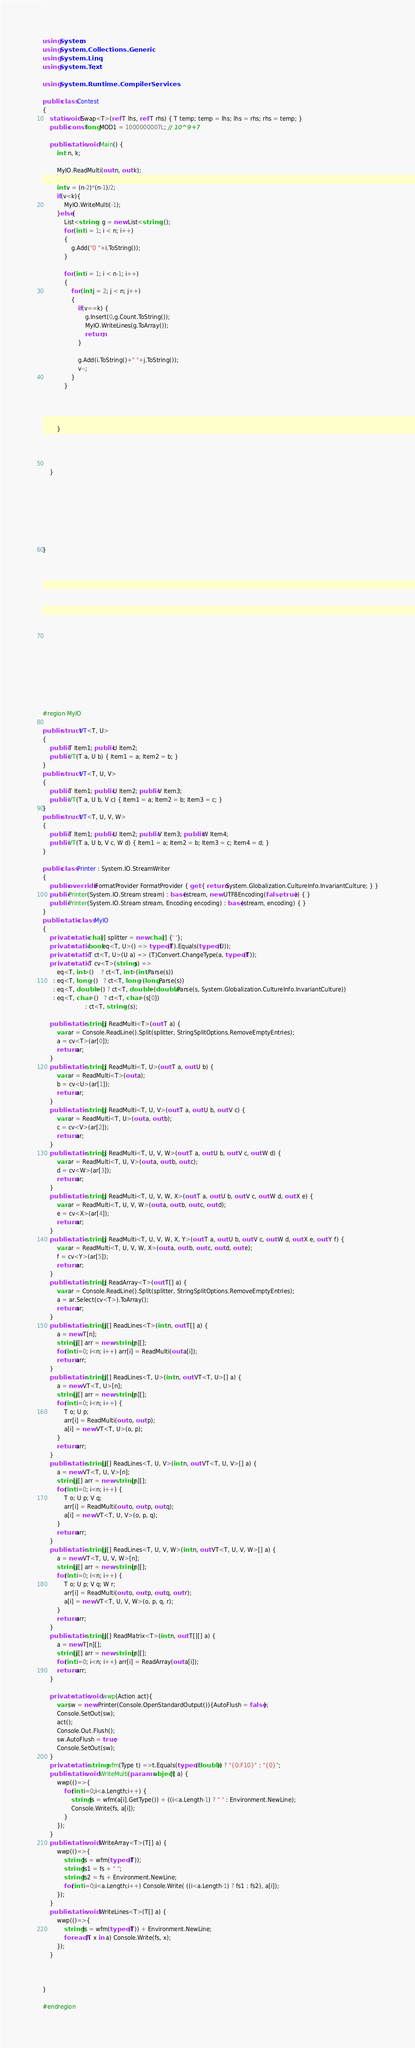Convert code to text. <code><loc_0><loc_0><loc_500><loc_500><_C#_>using System;
using System.Collections.Generic;
using System.Linq;
using System.Text;

using System.Runtime.CompilerServices;

public class Contest
{
	static void Swap<T>(ref T lhs, ref T rhs) { T temp; temp = lhs; lhs = rhs; rhs = temp; }
	public const long MOD1 = 1000000007L; // 10^9+7

	public static void Main() {
		int  n, k;

		MyIO.ReadMulti(out n, out k);
 
		int v = (n-2)*(n-1)/2;
		if(v<k){
			MyIO.WriteMulti(-1);
		}else{
			List<string> g = new List<string>();
			for (int i = 1; i < n; i++)
			{
				g.Add("0 "+i.ToString());
			}

			for (int i = 1; i < n-1; i++)
			{
				for (int j = 2; j < n; j++)
				{
					if(v==k) {
						g.Insert(0,g.Count.ToString());
						MyIO.WriteLines(g.ToArray());
						return;
					}				

					g.Add(i.ToString()+" "+j.ToString());
					v--;
				}				
			}




		}



 
	}








}


















#region MyIO

public struct VT<T, U>
{
	public T Item1; public U Item2;
    public VT(T a, U b) { Item1 = a; Item2 = b; }
}
public struct VT<T, U, V>
{
	public T Item1; public U Item2; public V Item3;
    public VT(T a, U b, V c) { Item1 = a; Item2 = b; Item3 = c; }
}
public struct VT<T, U, V, W>
{
	public T Item1; public U Item2; public V Item3; public W Item4;
    public VT(T a, U b, V c, W d) { Item1 = a; Item2 = b; Item3 = c; Item4 = d; }
}

public class Printer : System.IO.StreamWriter
{
	public override IFormatProvider FormatProvider { get { return System.Globalization.CultureInfo.InvariantCulture; } }
	public Printer(System.IO.Stream stream) : base(stream, new UTF8Encoding(false, true)) { }
	public Printer(System.IO.Stream stream, Encoding encoding) : base(stream, encoding) { }
}
public static class MyIO
{
	private static char[] splitter = new char[] {' '};
	private static bool eq<T, U>() => typeof(T).Equals(typeof(U));
	private static T ct<T, U>(U a) => (T)Convert.ChangeType(a, typeof(T));
	private static T cv<T>(string s) =>
		eq<T, int>()    ? ct<T, int>(int.Parse(s))
	  : eq<T, long>()   ? ct<T, long>(long.Parse(s))
	  : eq<T, double>() ? ct<T, double>(double.Parse(s, System.Globalization.CultureInfo.InvariantCulture))
	  : eq<T, char>()   ? ct<T, char>(s[0])
						: ct<T, string>(s);
			
	public static string[] ReadMulti<T>(out T a) {
		var ar = Console.ReadLine().Split(splitter, StringSplitOptions.RemoveEmptyEntries); 
		a = cv<T>(ar[0]);
		return ar;
	}
	public static string[] ReadMulti<T, U>(out T a, out U b) {
		var ar = ReadMulti<T>(out a); 
        b = cv<U>(ar[1]);
		return ar;
	}
	public static string[] ReadMulti<T, U, V>(out T a, out U b, out V c) {
		var ar = ReadMulti<T, U>(out a, out b); 
        c = cv<V>(ar[2]);
		return ar;
	}
	public static string[] ReadMulti<T, U, V, W>(out T a, out U b, out V c, out W d) {
		var ar = ReadMulti<T, U, V>(out a, out b, out c); 
        d = cv<W>(ar[3]);
		return ar;
	}
	public static string[] ReadMulti<T, U, V, W, X>(out T a, out U b, out V c, out W d, out X e) {
		var ar = ReadMulti<T, U, V, W>(out a, out b, out c, out d); 
        e = cv<X>(ar[4]);
		return ar;
	}
	public static string[] ReadMulti<T, U, V, W, X, Y>(out T a, out U b, out V c, out W d, out X e, out Y f) {
		var ar = ReadMulti<T, U, V, W, X>(out a, out b, out c, out d, out e); 
        f = cv<Y>(ar[5]);
		return ar;
	}
	public static string[] ReadArray<T>(out T[] a) {		
		var ar = Console.ReadLine().Split(splitter, StringSplitOptions.RemoveEmptyEntries);
		a = ar.Select(cv<T>).ToArray();
		return ar;
	}		
	public static string[][] ReadLines<T>(int n, out T[] a) {
		a = new T[n];
		string[][] arr = new string[n][];
		for(int i=0; i<n; i++) arr[i] = ReadMulti(out a[i]);
		return arr;
	}
	public static string[][] ReadLines<T, U>(int n, out VT<T, U>[] a) {
		a = new VT<T, U>[n];
		string[][] arr = new string[n][];
		for(int i=0; i<n; i++) {
			T o; U p;
			arr[i] = ReadMulti(out o, out p);
			a[i] = new VT<T, U>(o, p);
		}
		return arr;
	}
	public static string[][] ReadLines<T, U, V>(int n, out VT<T, U, V>[] a) {
		a = new VT<T, U, V>[n];
		string[][] arr = new string[n][];
		for(int i=0; i<n; i++) {
			T o; U p; V q;
			arr[i] = ReadMulti(out o, out p, out q);
			a[i] = new VT<T, U, V>(o, p, q);
		}
		return arr;
	}
	public static string[][] ReadLines<T, U, V, W>(int n, out VT<T, U, V, W>[] a) {
		a = new VT<T, U, V, W>[n];
		string[][] arr = new string[n][];
		for(int i=0; i<n; i++) {
			T o; U p; V q; W r;
			arr[i] = ReadMulti(out o, out p, out q, out r);
			a[i] = new VT<T, U, V, W>(o, p, q, r);
		}
		return arr;
	}
	public static string[][] ReadMatrix<T>(int n, out T[][] a) {
		a = new T[n][];
		string[][] arr = new string[n][];
		for(int i=0; i<n; i++) arr[i] = ReadArray(out a[i]);
		return arr;
	}

	private static void wwp(Action act){
		var sw = new Printer(Console.OpenStandardOutput()){AutoFlush = false};
		Console.SetOut(sw);
		act();
		Console.Out.Flush();
		sw.AutoFlush = true;
		Console.SetOut(sw);
	}
	private static string wfm(Type t) =>t.Equals(typeof(double)) ? "{0:F10}" : "{0}";
	public static void WriteMulti(params object[] a) {
		wwp(()=>{
			for(int i=0;i<a.Length;i++) {
				string fs = wfm(a[i].GetType()) + ((i<a.Length-1) ? " " : Environment.NewLine);
				Console.Write(fs, a[i]);
			}
		});
	}
	public static void WriteArray<T>(T[] a) {
		wwp(()=>{
			string fs = wfm(typeof(T));
			string fs1 = fs + " ";
			string fs2 = fs + Environment.NewLine;
			for(int i=0;i<a.Length;i++) Console.Write( ((i<a.Length-1) ? fs1 : fs2), a[i]);
		});
	}
	public static void WriteLines<T>(T[] a) {
		wwp(()=>{
			string fs = wfm(typeof(T)) + Environment.NewLine;
			foreach(T x in a) Console.Write(fs, x);
		});
	}



}

#endregion

</code> 